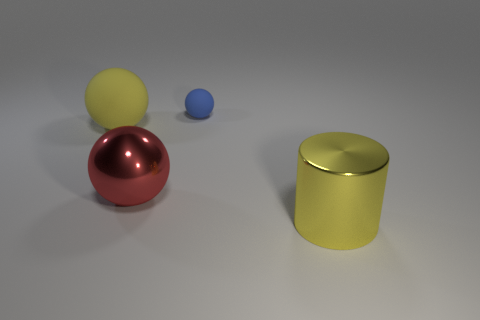Add 3 balls. How many objects exist? 7 Subtract all cylinders. How many objects are left? 3 Add 4 tiny cyan spheres. How many tiny cyan spheres exist? 4 Subtract 0 yellow blocks. How many objects are left? 4 Subtract all large red cylinders. Subtract all metal things. How many objects are left? 2 Add 3 cylinders. How many cylinders are left? 4 